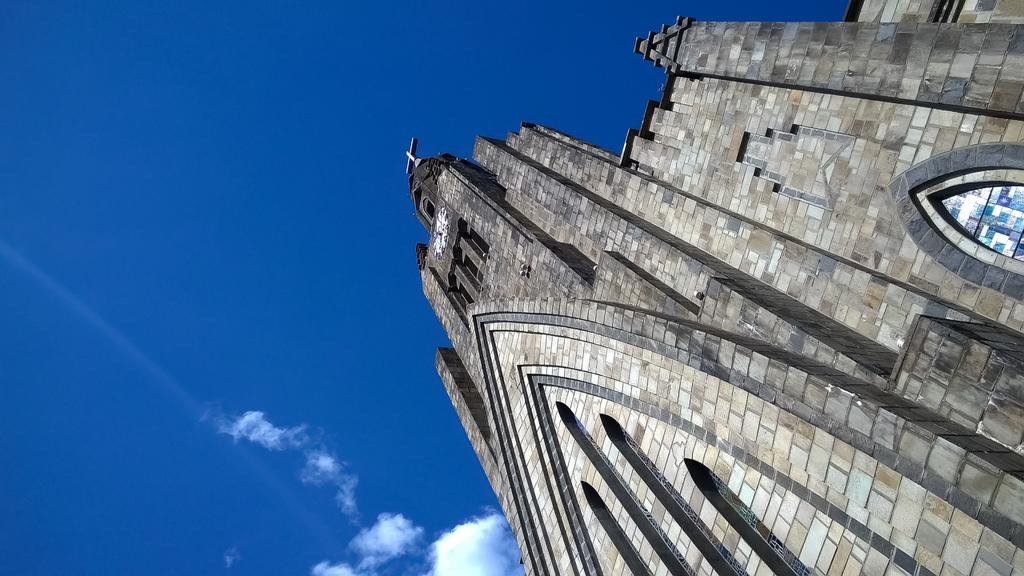What type of structure is present in the image? There is a building in the image. What can be seen in the background of the image? The sky is visible in the background of the image. What is the condition of the sky in the image? The sky is clear in the image. What type of iron is being used to press the silk suit in the image? There is no iron, silk, or suit present in the image. 